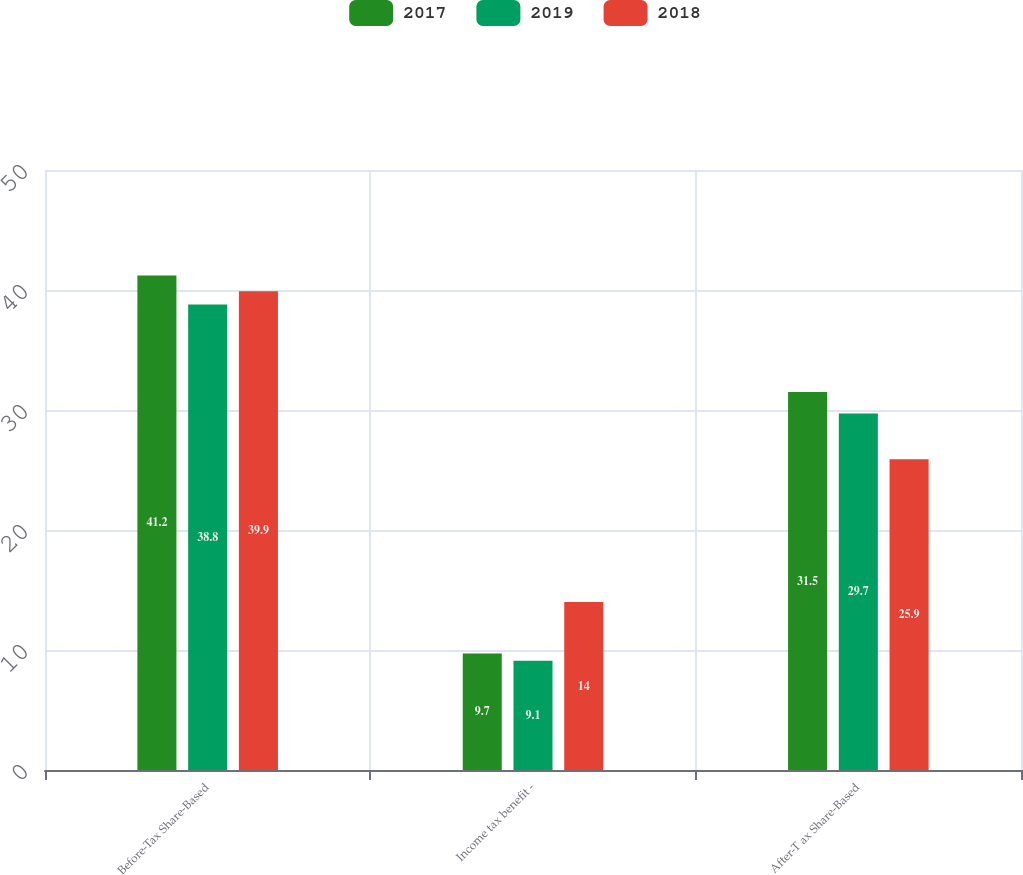Convert chart. <chart><loc_0><loc_0><loc_500><loc_500><stacked_bar_chart><ecel><fcel>Before-Tax Share-Based<fcel>Income tax benefit -<fcel>After-T ax Share-Based<nl><fcel>2017<fcel>41.2<fcel>9.7<fcel>31.5<nl><fcel>2019<fcel>38.8<fcel>9.1<fcel>29.7<nl><fcel>2018<fcel>39.9<fcel>14<fcel>25.9<nl></chart> 